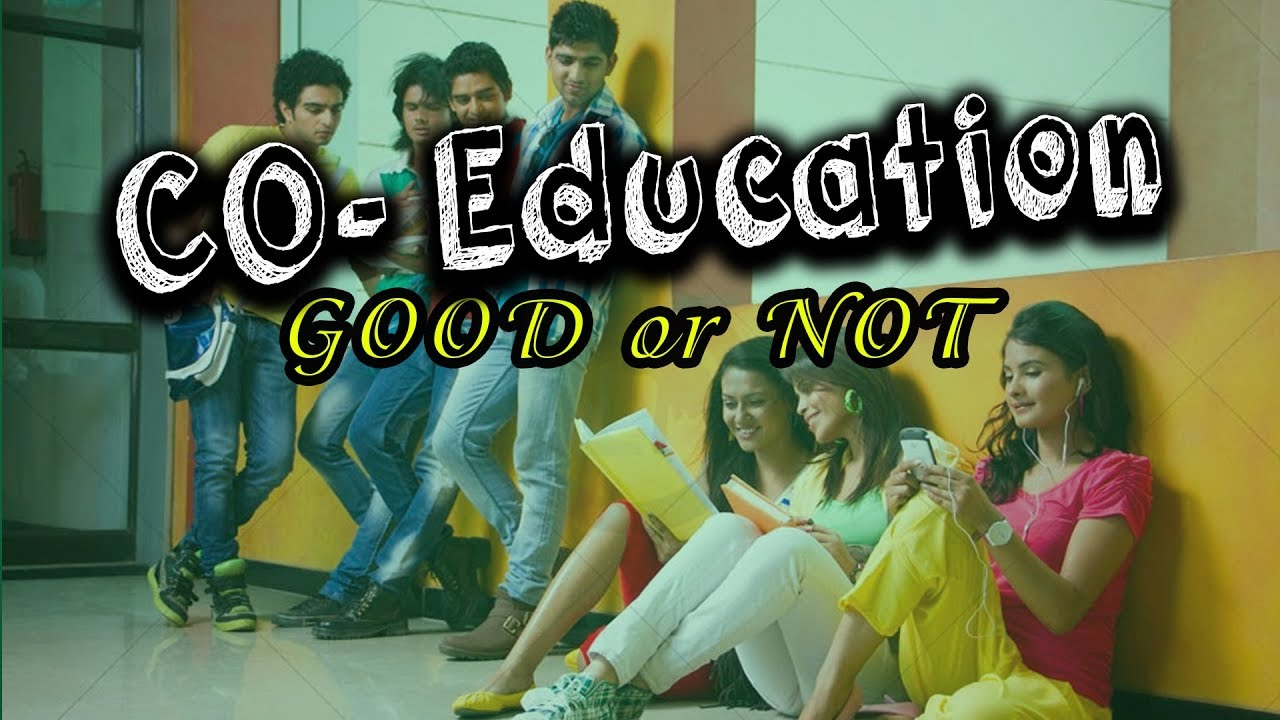What are the potential subjects that the individuals in the image might be studying or discussing? Given their casual attire and the informal setting, the individuals could be engaged in a range of subjects. The presence of notebooks and a book suggests they could be discussing academic coursework, perhaps for a liberal arts subject given the lack of technical or scientific paraphernalia. Their conversation might revolve around a group project or preparation for a class presentation. What time of day does the lighting in the image suggest, and how might that affect the activity of the individuals? The indoor lighting gives an impression of midday or afternoon brightness, which does not indicate the time of day conclusively. However, if it is indeed afternoon, this might be a time when energy levels could be waning, leading to a more relaxed posture and possibly less intense study sessions. It might also be a break period, where students are recapping the day's lectures or preparing for upcoming classes. 